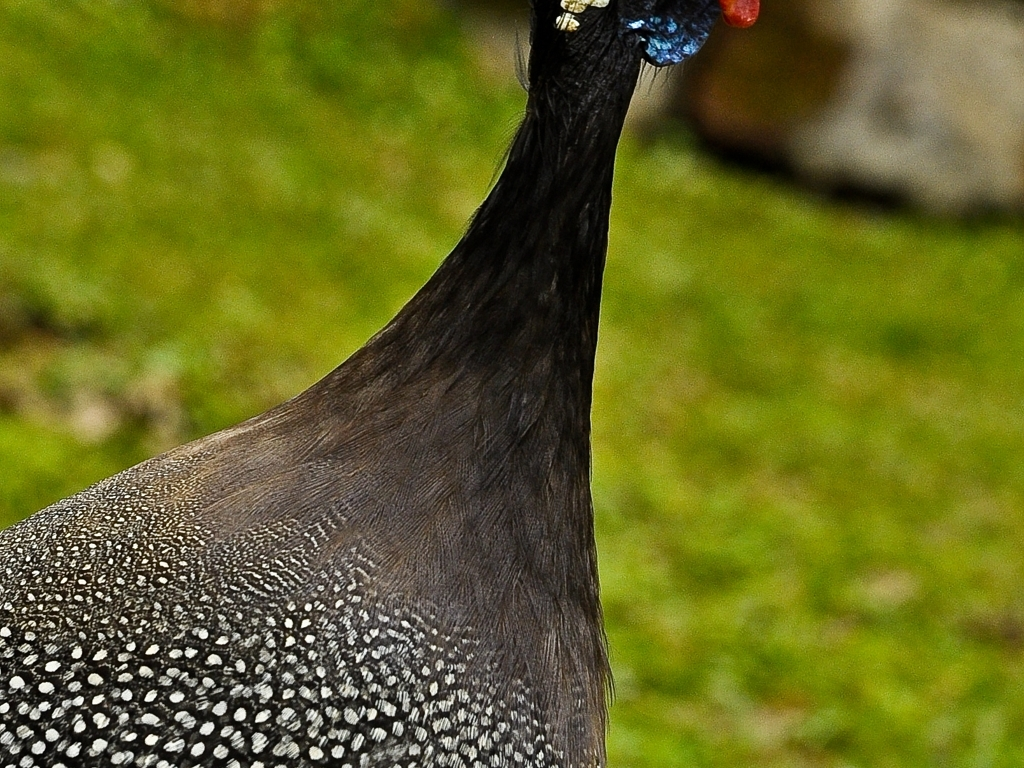Does the main subject of the peacock retain its details and textures?
A. No
B. Yes
Answer with the option's letter from the given choices directly.
 B. 